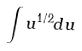<formula> <loc_0><loc_0><loc_500><loc_500>\int u ^ { 1 / 2 } d u</formula> 